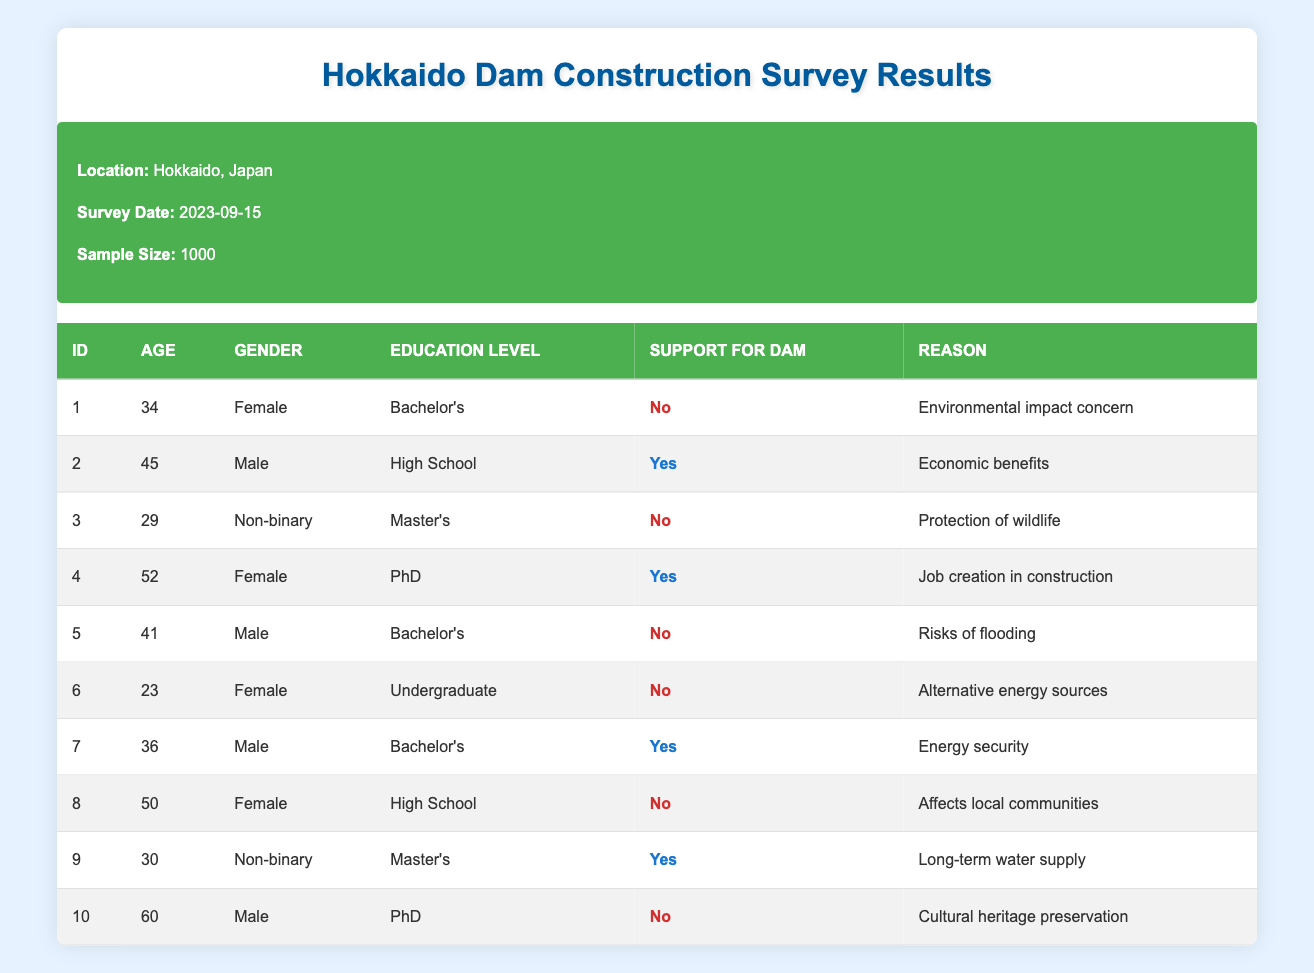What percentage of respondents support dam construction? There are 1000 total responses. Out of these, 4 respondents support the dam (Respondent IDs 2, 4, 7, and 9). The percentage is calculated as (4/1000) * 100 = 0.4%.
Answer: 0.4% How many respondents aged 40 and above oppose the dam? The respondents aged 40 and above are Respondent IDs 2, 4, 5, 8, and 10. Among these, Respondent IDs 5, 8, and 10 oppose the dam. Therefore, 3 out of these 5 respondents oppose the dam.
Answer: 3 Is there a gender that shows more support for dam construction? Out of those who support the dam (4 respondents), 2 are male (ID 2 and ID 7) and 1 is female (ID 4). The other one is non-binary (ID 9). Since males have more supporters, the gender showing more support is male.
Answer: Yes, male Which reasons for opposing the dam are mentioned by female respondents? The female respondents who oppose the dam are ID 1, ID 5, and ID 8. Their reasons are: ID 1 - environmental impact concern, ID 5 - risks of flooding, and ID 8 - affects local communities.
Answer: Environmental impact concern, risks of flooding, affects local communities What is the average age of respondents who support the dam? The ages of the respondents who support the dam are 45 (ID 2), 52 (ID 4), 36 (ID 7), and 30 (ID 9). The sum of these ages is 45 + 52 + 36 + 30 = 163. The average is calculated as 163 / 4 = 40.75.
Answer: 40.75 What reasons for supporting the dam are provided by respondents aged 35 and above? The respondents aged 35 and above who support the dam are ID 2 (economic benefits), ID 4 (job creation in construction), and ID 7 (energy security). Therefore, the reasons are economic benefits, job creation in construction, and energy security.
Answer: Economic benefits, job creation in construction, energy security Are there more respondents with a Bachelor's degree who oppose or support the dam? Among the respondents, those with a Bachelor's degree are ID 1 (opposes), ID 2 (supports), ID 5 (opposes), and ID 7 (supports). There are 2 supporters (IDs 2 and 7) and 2 opposers (IDs 1 and 5), so the numbers are equal.
Answer: Equal How many respondents provided reasons related to environmental concerns? The respondents who mentioned environmental concerns are ID 1 (environmental impact concern), ID 3 (protection of wildlife), ID 5 (risks of flooding), ID 6 (alternative energy sources), and ID 8 (affects local communities). Hence, there are a total of 5 respondents who provided such reasons.
Answer: 5 What is the ratio of respondents with a Master's education level who support the dam to those who oppose it? There are 2 respondents with a Master's level (ID 3 - opposes and ID 9 - supports). This gives a ratio of 1:1 since one supports and one opposes the dam.
Answer: 1:1 